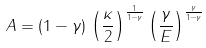Convert formula to latex. <formula><loc_0><loc_0><loc_500><loc_500>A = ( 1 - \gamma ) \, \left ( { \frac { \kappa } { 2 } } \right ) ^ { \frac { 1 } { 1 - \gamma } } \left ( { \frac { \gamma } { E } } \right ) ^ { \frac { \gamma } { 1 - \gamma } }</formula> 